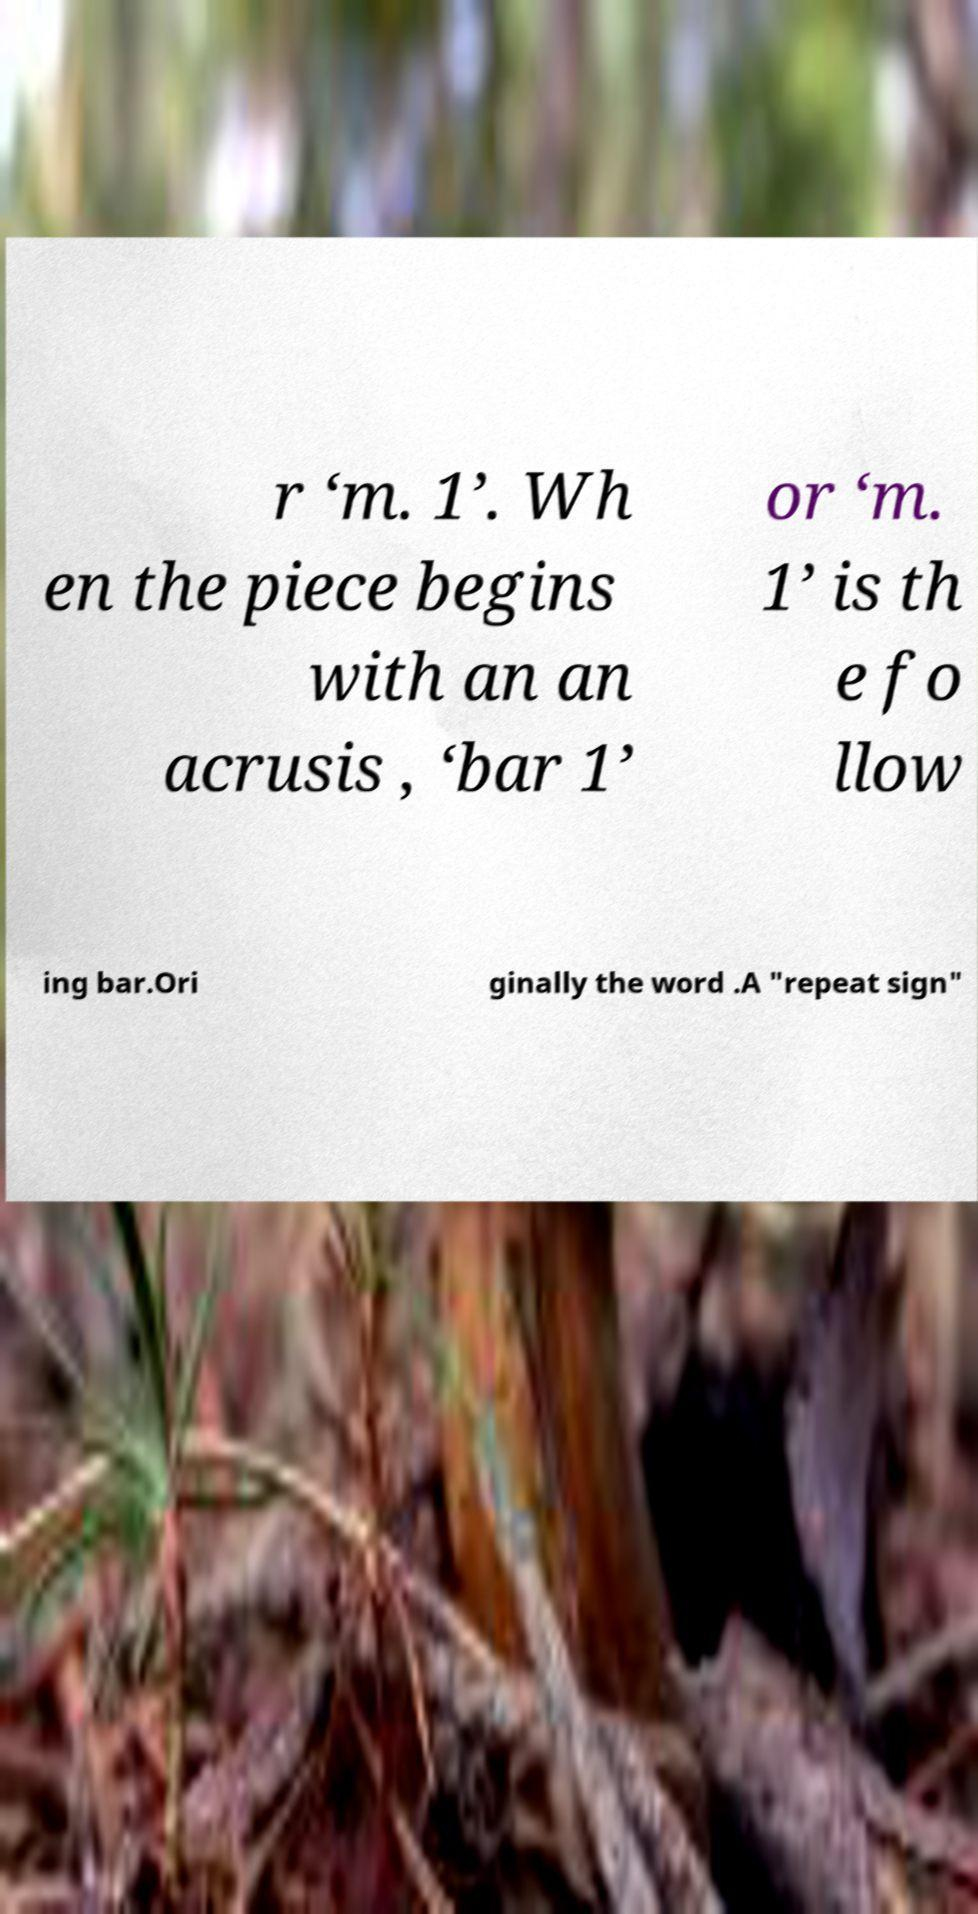There's text embedded in this image that I need extracted. Can you transcribe it verbatim? r ‘m. 1’. Wh en the piece begins with an an acrusis , ‘bar 1’ or ‘m. 1’ is th e fo llow ing bar.Ori ginally the word .A "repeat sign" 